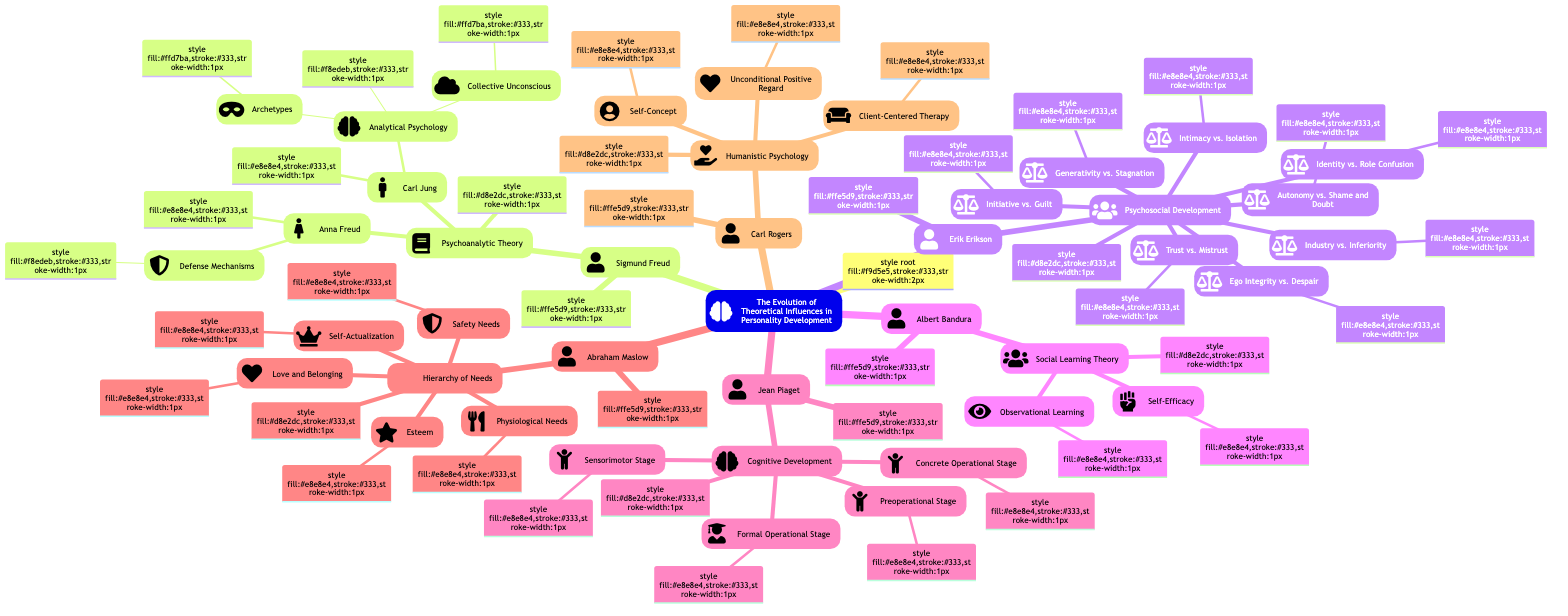What is the main theory associated with Erik Erikson? The main theory associated with Erik Erikson, as seen in the diagram branching from his name, is "Psychosocial Development." This is directly indicated as a child node under Erik Erikson.
Answer: Psychosocial Development How many stages are represented under Erik Erikson’s theory? By counting the child nodes listed under "Psychosocial Development," there are eight distinct stages presented: Trust vs. Mistrust, Autonomy vs. Shame and Doubt, Initiative vs. Guilt, Industry vs. Inferiority, Identity vs. Role Confusion, Intimacy vs. Isolation, Generativity vs. Stagnation, and Ego Integrity vs. Despair.
Answer: 8 Who is associated with the concept of "Self-Efficacy"? The concept of "Self-Efficacy" is directly under the child node "Social Learning Theory," which belongs to Albert Bandura, as pointed out in the diagram.
Answer: Albert Bandura Which theorist introduced the notion of "Defense Mechanisms"? "Defense Mechanisms" is a child node under "Anna Freud," which is itself a child of "Psychoanalytic Theory." This establishes Anna Freud as the theorist who introduced the notion.
Answer: Anna Freud What relationship do Carl Jung and Sigmund Freud have in this diagram? In the diagram, Carl Jung is depicted as a child node under "Psychoanalytic Theory," which indicates his relationship as an associate or successor of Sigmund Freud's foundational theory while also expanding upon it with his own ideas.
Answer: Carl Jung What are the two sub-concepts related to Carl Jung’s theory? The two sub-concepts related to Carl Jung’s "Analytical Psychology" are "Archetypes" and "Collective Unconscious," both of which are listed as child nodes under that theory.
Answer: Archetypes, Collective Unconscious How is Abraham Maslow’s theory structured in the diagram? Abraham Maslow’s "Hierarchy of Needs" is structured with five child nodes detailing different needs: Physiological Needs, Safety Needs, Love and Belonging, Esteem, and Self-Actualization. This hierarchical organization highlights the progressive nature of his theory.
Answer: Hierarchy of Needs What common theme is shared among the theories presented in this diagram? A common theme among the theories is the focus on human development and behavior, including how personality evolves through stages or influences like psychosocial dynamics, cognitive development, learning from observation, and fulfilling needs.
Answer: Human development and behavior What does each sub-stage under Jean Piaget’s theory represent? Each sub-stage under Jean Piaget’s "Cognitive Development"—the Sensorimotor Stage, Preoperational Stage, Concrete Operational Stage, and Formal Operational Stage—represents different phases in a child's learning and cognitive growth as they interact with the world.
Answer: Different phases in cognitive growth 